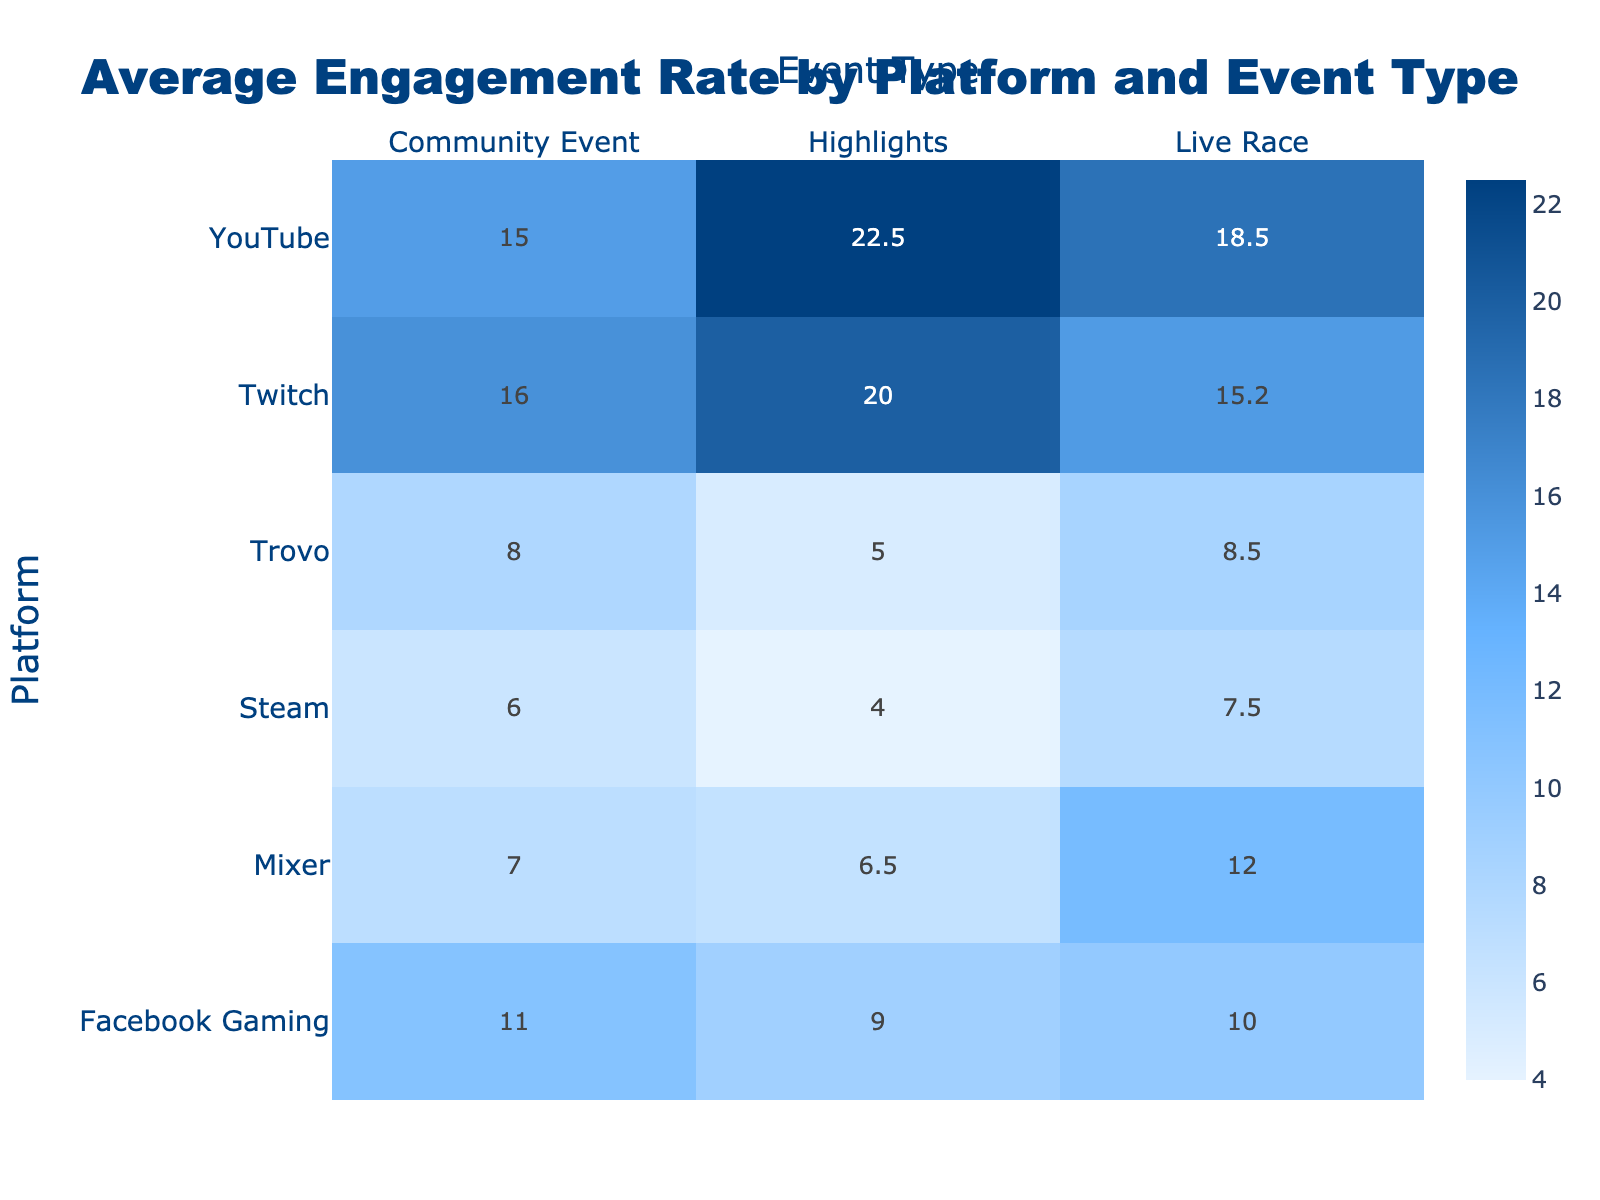What is the highest engagement rate recorded for a platform during a Live Race event? By looking at the table, the engagement rates for Live Race events are: Twitch (15.2), YouTube (18.5), Facebook Gaming (10.0), Trovo (8.5), Mixer (12.0), and Steam (7.5). The maximum value among these is 18.5, which corresponds to YouTube.
Answer: 18.5 Which platform had the lowest engagement rate in the Highlights event type? In the Highlights event type, the engagement rates are: Twitch (20.0), YouTube (22.5), Facebook Gaming (9.0), Trovo (5.0), Mixer (6.5), and Steam (4.0). The lowest engagement rate is 4.0, which corresponds to Steam.
Answer: Steam Calculate the average engagement rate for Twitch across all event types. The engagement rates for Twitch are: Live Race (15.2), Highlights (20.0), and Community Event (16.0). To find the average, sum these values (15.2 + 20.0 + 16.0 = 51.2) and divide by the number of events (3). Thus, the average engagement rate for Twitch is 51.2 / 3 = 17.07.
Answer: 17.1 Is it true that Facebook Gaming has a higher engagement rate in Community Events compared to Trovo? The engagement rates for Facebook Gaming in Community Events is 11.0 and for Trovo, it is 8.0. Since 11.0 is greater than 8.0, this statement is true.
Answer: Yes What is the total number of comments across all platforms for Live Race events? The number of comments for Live Race events are: Twitch (350), YouTube (200), Facebook Gaming (75), Trovo (50), Mixer (120), and Steam (30). Adding these gives (350 + 200 + 75 + 50 + 120 + 30 = 925). Thus, the total number of comments for Live Race events is 925.
Answer: 925 